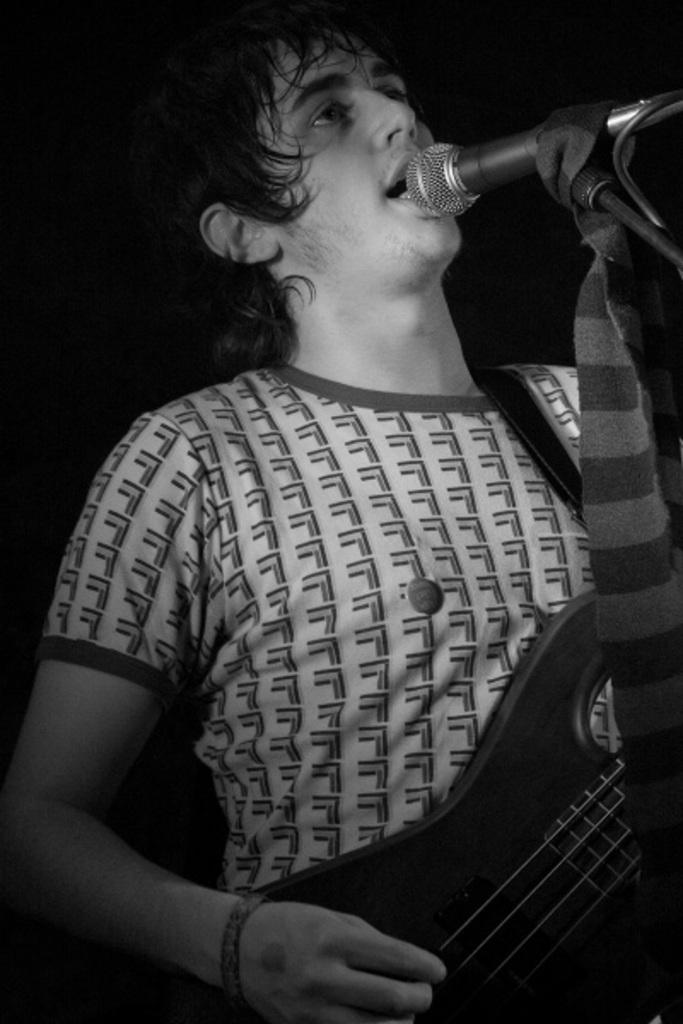Who is the main subject in the image? There is a man in the image. What is the man holding in the image? The man is holding a guitar. What object is in front of the man? There is a microphone in front of the man. What is the color scheme of the image? The image is in black and white. How does the letter fly in the wind in the image? There is no letter or wind present in the image; it is a man holding a guitar with a microphone in front of him. 